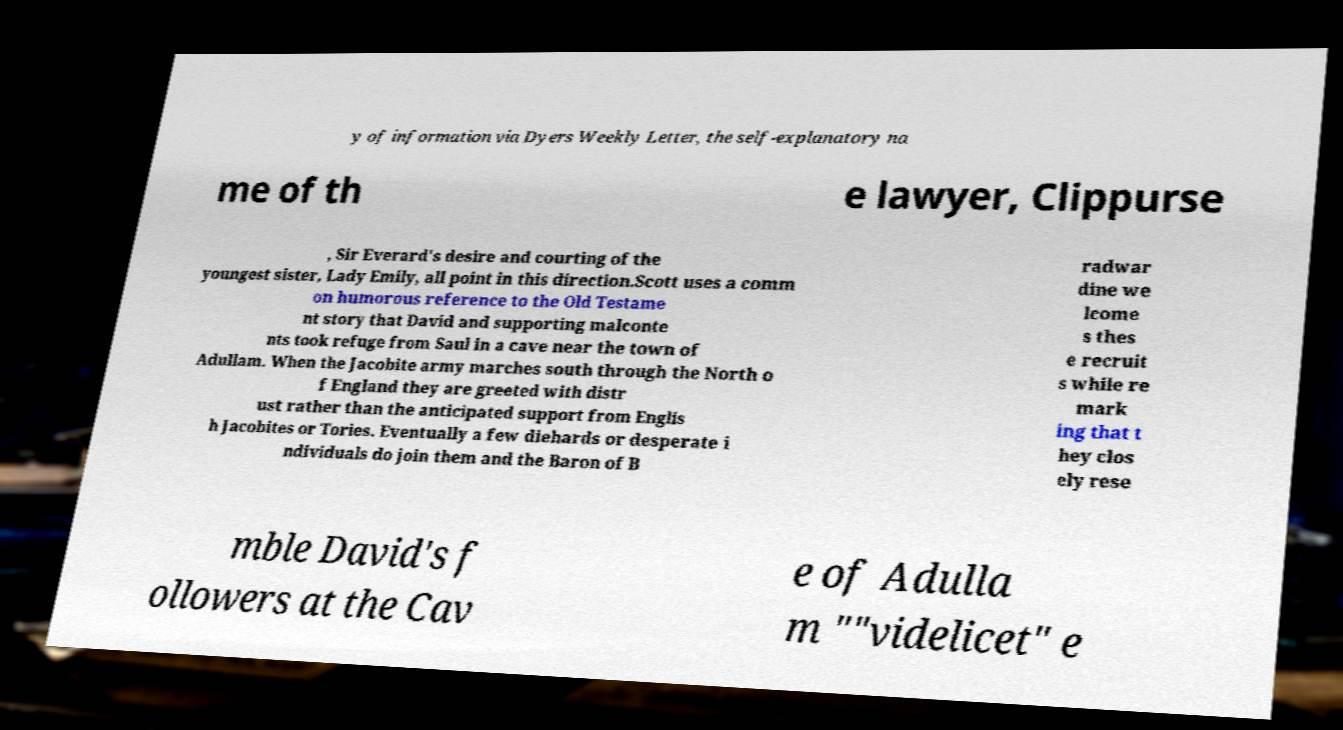Please identify and transcribe the text found in this image. y of information via Dyers Weekly Letter, the self-explanatory na me of th e lawyer, Clippurse , Sir Everard's desire and courting of the youngest sister, Lady Emily, all point in this direction.Scott uses a comm on humorous reference to the Old Testame nt story that David and supporting malconte nts took refuge from Saul in a cave near the town of Adullam. When the Jacobite army marches south through the North o f England they are greeted with distr ust rather than the anticipated support from Englis h Jacobites or Tories. Eventually a few diehards or desperate i ndividuals do join them and the Baron of B radwar dine we lcome s thes e recruit s while re mark ing that t hey clos ely rese mble David's f ollowers at the Cav e of Adulla m ""videlicet" e 